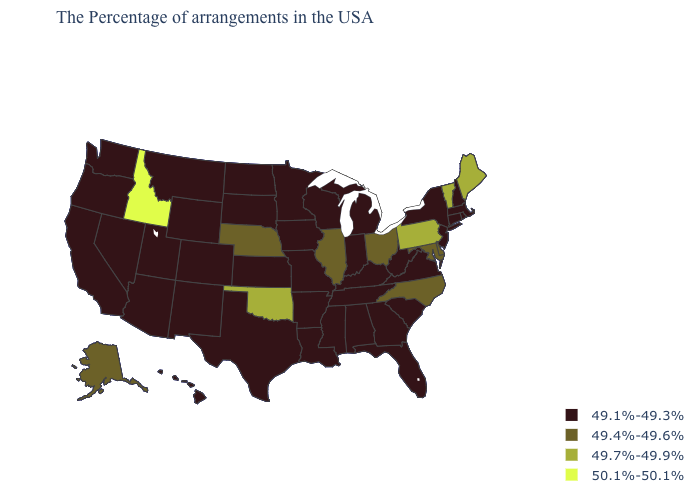Among the states that border Oklahoma , which have the highest value?
Answer briefly. Missouri, Arkansas, Kansas, Texas, Colorado, New Mexico. Does Florida have the lowest value in the USA?
Concise answer only. Yes. Is the legend a continuous bar?
Write a very short answer. No. What is the lowest value in the MidWest?
Write a very short answer. 49.1%-49.3%. Does the first symbol in the legend represent the smallest category?
Concise answer only. Yes. Does Utah have a higher value than Iowa?
Answer briefly. No. Does New Mexico have the lowest value in the USA?
Be succinct. Yes. What is the lowest value in states that border Louisiana?
Answer briefly. 49.1%-49.3%. Name the states that have a value in the range 50.1%-50.1%?
Write a very short answer. Idaho. Name the states that have a value in the range 49.1%-49.3%?
Short answer required. Massachusetts, Rhode Island, New Hampshire, Connecticut, New York, New Jersey, Virginia, South Carolina, West Virginia, Florida, Georgia, Michigan, Kentucky, Indiana, Alabama, Tennessee, Wisconsin, Mississippi, Louisiana, Missouri, Arkansas, Minnesota, Iowa, Kansas, Texas, South Dakota, North Dakota, Wyoming, Colorado, New Mexico, Utah, Montana, Arizona, Nevada, California, Washington, Oregon, Hawaii. What is the value of Iowa?
Write a very short answer. 49.1%-49.3%. What is the value of South Carolina?
Write a very short answer. 49.1%-49.3%. Name the states that have a value in the range 49.7%-49.9%?
Be succinct. Maine, Vermont, Pennsylvania, Oklahoma. Name the states that have a value in the range 49.1%-49.3%?
Quick response, please. Massachusetts, Rhode Island, New Hampshire, Connecticut, New York, New Jersey, Virginia, South Carolina, West Virginia, Florida, Georgia, Michigan, Kentucky, Indiana, Alabama, Tennessee, Wisconsin, Mississippi, Louisiana, Missouri, Arkansas, Minnesota, Iowa, Kansas, Texas, South Dakota, North Dakota, Wyoming, Colorado, New Mexico, Utah, Montana, Arizona, Nevada, California, Washington, Oregon, Hawaii. Does North Dakota have the same value as Alaska?
Concise answer only. No. 